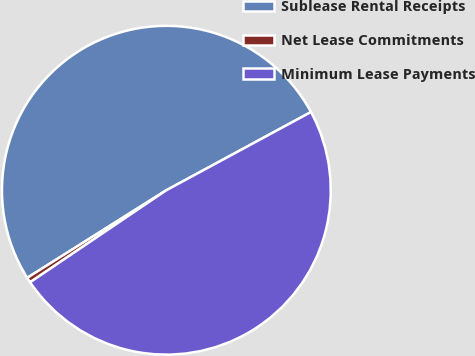Convert chart to OTSL. <chart><loc_0><loc_0><loc_500><loc_500><pie_chart><fcel>Sublease Rental Receipts<fcel>Net Lease Commitments<fcel>Minimum Lease Payments<nl><fcel>51.06%<fcel>0.51%<fcel>48.44%<nl></chart> 